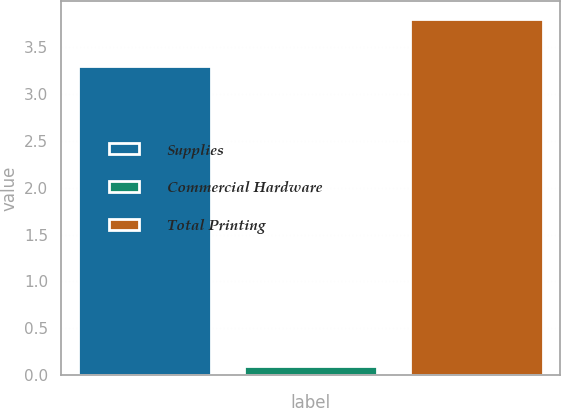<chart> <loc_0><loc_0><loc_500><loc_500><bar_chart><fcel>Supplies<fcel>Commercial Hardware<fcel>Total Printing<nl><fcel>3.3<fcel>0.1<fcel>3.8<nl></chart> 